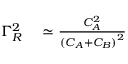Convert formula to latex. <formula><loc_0><loc_0><loc_500><loc_500>\begin{array} { r l } { \Gamma _ { R } ^ { 2 } } & \simeq \frac { C _ { A } ^ { 2 } } { { ( C _ { A } + C _ { B } ) } ^ { 2 } } } \end{array}</formula> 